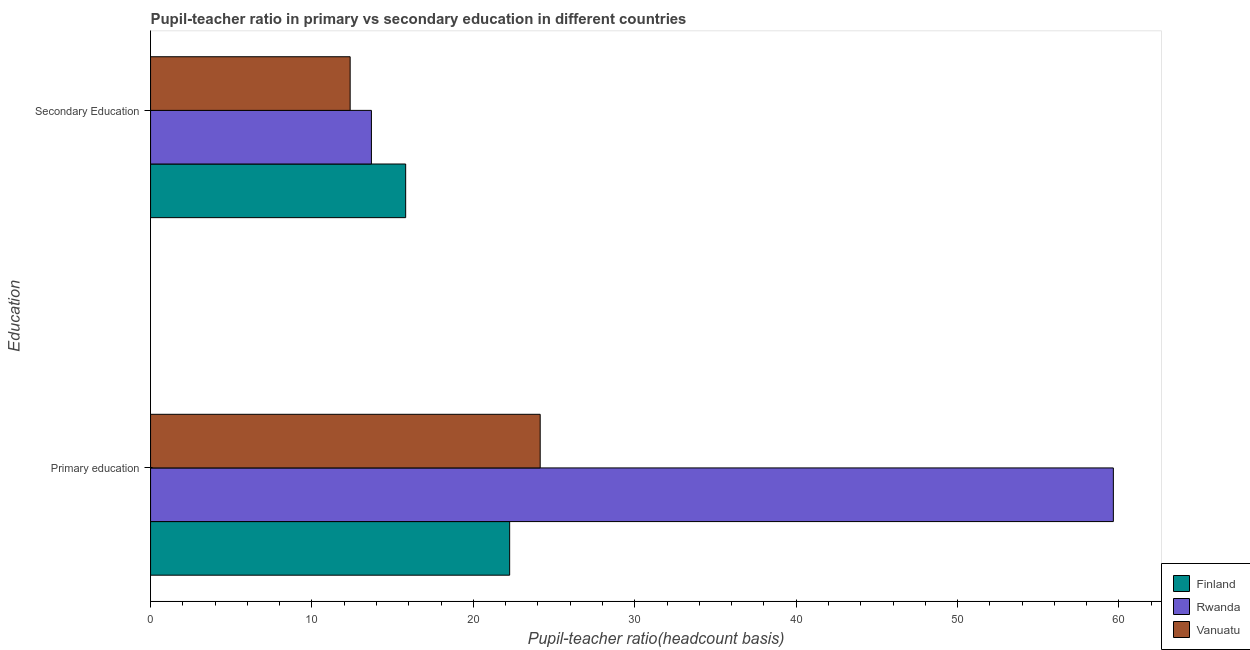How many different coloured bars are there?
Your response must be concise. 3. Are the number of bars per tick equal to the number of legend labels?
Ensure brevity in your answer.  Yes. Are the number of bars on each tick of the Y-axis equal?
Offer a terse response. Yes. How many bars are there on the 2nd tick from the top?
Provide a short and direct response. 3. What is the label of the 1st group of bars from the top?
Offer a terse response. Secondary Education. What is the pupil-teacher ratio in primary education in Rwanda?
Give a very brief answer. 59.65. Across all countries, what is the maximum pupil teacher ratio on secondary education?
Keep it short and to the point. 15.81. Across all countries, what is the minimum pupil teacher ratio on secondary education?
Your answer should be very brief. 12.37. In which country was the pupil-teacher ratio in primary education maximum?
Make the answer very short. Rwanda. In which country was the pupil teacher ratio on secondary education minimum?
Your response must be concise. Vanuatu. What is the total pupil-teacher ratio in primary education in the graph?
Keep it short and to the point. 106.04. What is the difference between the pupil-teacher ratio in primary education in Vanuatu and that in Finland?
Offer a terse response. 1.89. What is the difference between the pupil teacher ratio on secondary education in Rwanda and the pupil-teacher ratio in primary education in Vanuatu?
Your answer should be very brief. -10.46. What is the average pupil-teacher ratio in primary education per country?
Provide a succinct answer. 35.35. What is the difference between the pupil-teacher ratio in primary education and pupil teacher ratio on secondary education in Vanuatu?
Keep it short and to the point. 11.77. What is the ratio of the pupil teacher ratio on secondary education in Rwanda to that in Finland?
Make the answer very short. 0.87. Is the pupil-teacher ratio in primary education in Finland less than that in Rwanda?
Ensure brevity in your answer.  Yes. What does the 3rd bar from the top in Primary education represents?
Keep it short and to the point. Finland. What does the 3rd bar from the bottom in Primary education represents?
Provide a short and direct response. Vanuatu. What is the difference between two consecutive major ticks on the X-axis?
Your answer should be very brief. 10. Does the graph contain any zero values?
Your answer should be compact. No. How are the legend labels stacked?
Give a very brief answer. Vertical. What is the title of the graph?
Your answer should be compact. Pupil-teacher ratio in primary vs secondary education in different countries. What is the label or title of the X-axis?
Keep it short and to the point. Pupil-teacher ratio(headcount basis). What is the label or title of the Y-axis?
Make the answer very short. Education. What is the Pupil-teacher ratio(headcount basis) of Finland in Primary education?
Keep it short and to the point. 22.25. What is the Pupil-teacher ratio(headcount basis) of Rwanda in Primary education?
Offer a terse response. 59.65. What is the Pupil-teacher ratio(headcount basis) of Vanuatu in Primary education?
Offer a terse response. 24.14. What is the Pupil-teacher ratio(headcount basis) of Finland in Secondary Education?
Give a very brief answer. 15.81. What is the Pupil-teacher ratio(headcount basis) in Rwanda in Secondary Education?
Your answer should be very brief. 13.68. What is the Pupil-teacher ratio(headcount basis) of Vanuatu in Secondary Education?
Make the answer very short. 12.37. Across all Education, what is the maximum Pupil-teacher ratio(headcount basis) in Finland?
Your answer should be very brief. 22.25. Across all Education, what is the maximum Pupil-teacher ratio(headcount basis) in Rwanda?
Provide a short and direct response. 59.65. Across all Education, what is the maximum Pupil-teacher ratio(headcount basis) of Vanuatu?
Provide a short and direct response. 24.14. Across all Education, what is the minimum Pupil-teacher ratio(headcount basis) in Finland?
Your response must be concise. 15.81. Across all Education, what is the minimum Pupil-teacher ratio(headcount basis) in Rwanda?
Provide a succinct answer. 13.68. Across all Education, what is the minimum Pupil-teacher ratio(headcount basis) of Vanuatu?
Provide a succinct answer. 12.37. What is the total Pupil-teacher ratio(headcount basis) in Finland in the graph?
Provide a succinct answer. 38.05. What is the total Pupil-teacher ratio(headcount basis) of Rwanda in the graph?
Provide a succinct answer. 73.34. What is the total Pupil-teacher ratio(headcount basis) of Vanuatu in the graph?
Your response must be concise. 36.51. What is the difference between the Pupil-teacher ratio(headcount basis) of Finland in Primary education and that in Secondary Education?
Ensure brevity in your answer.  6.44. What is the difference between the Pupil-teacher ratio(headcount basis) in Rwanda in Primary education and that in Secondary Education?
Provide a short and direct response. 45.97. What is the difference between the Pupil-teacher ratio(headcount basis) in Vanuatu in Primary education and that in Secondary Education?
Offer a very short reply. 11.77. What is the difference between the Pupil-teacher ratio(headcount basis) in Finland in Primary education and the Pupil-teacher ratio(headcount basis) in Rwanda in Secondary Education?
Offer a very short reply. 8.56. What is the difference between the Pupil-teacher ratio(headcount basis) in Finland in Primary education and the Pupil-teacher ratio(headcount basis) in Vanuatu in Secondary Education?
Your response must be concise. 9.88. What is the difference between the Pupil-teacher ratio(headcount basis) of Rwanda in Primary education and the Pupil-teacher ratio(headcount basis) of Vanuatu in Secondary Education?
Your answer should be compact. 47.29. What is the average Pupil-teacher ratio(headcount basis) in Finland per Education?
Your answer should be compact. 19.03. What is the average Pupil-teacher ratio(headcount basis) in Rwanda per Education?
Offer a terse response. 36.67. What is the average Pupil-teacher ratio(headcount basis) in Vanuatu per Education?
Offer a very short reply. 18.25. What is the difference between the Pupil-teacher ratio(headcount basis) in Finland and Pupil-teacher ratio(headcount basis) in Rwanda in Primary education?
Make the answer very short. -37.4. What is the difference between the Pupil-teacher ratio(headcount basis) of Finland and Pupil-teacher ratio(headcount basis) of Vanuatu in Primary education?
Offer a terse response. -1.89. What is the difference between the Pupil-teacher ratio(headcount basis) in Rwanda and Pupil-teacher ratio(headcount basis) in Vanuatu in Primary education?
Provide a succinct answer. 35.51. What is the difference between the Pupil-teacher ratio(headcount basis) of Finland and Pupil-teacher ratio(headcount basis) of Rwanda in Secondary Education?
Offer a terse response. 2.12. What is the difference between the Pupil-teacher ratio(headcount basis) of Finland and Pupil-teacher ratio(headcount basis) of Vanuatu in Secondary Education?
Ensure brevity in your answer.  3.44. What is the difference between the Pupil-teacher ratio(headcount basis) of Rwanda and Pupil-teacher ratio(headcount basis) of Vanuatu in Secondary Education?
Ensure brevity in your answer.  1.32. What is the ratio of the Pupil-teacher ratio(headcount basis) of Finland in Primary education to that in Secondary Education?
Provide a succinct answer. 1.41. What is the ratio of the Pupil-teacher ratio(headcount basis) of Rwanda in Primary education to that in Secondary Education?
Your answer should be compact. 4.36. What is the ratio of the Pupil-teacher ratio(headcount basis) of Vanuatu in Primary education to that in Secondary Education?
Offer a very short reply. 1.95. What is the difference between the highest and the second highest Pupil-teacher ratio(headcount basis) of Finland?
Provide a short and direct response. 6.44. What is the difference between the highest and the second highest Pupil-teacher ratio(headcount basis) of Rwanda?
Give a very brief answer. 45.97. What is the difference between the highest and the second highest Pupil-teacher ratio(headcount basis) of Vanuatu?
Ensure brevity in your answer.  11.77. What is the difference between the highest and the lowest Pupil-teacher ratio(headcount basis) of Finland?
Your answer should be very brief. 6.44. What is the difference between the highest and the lowest Pupil-teacher ratio(headcount basis) of Rwanda?
Offer a terse response. 45.97. What is the difference between the highest and the lowest Pupil-teacher ratio(headcount basis) of Vanuatu?
Provide a short and direct response. 11.77. 